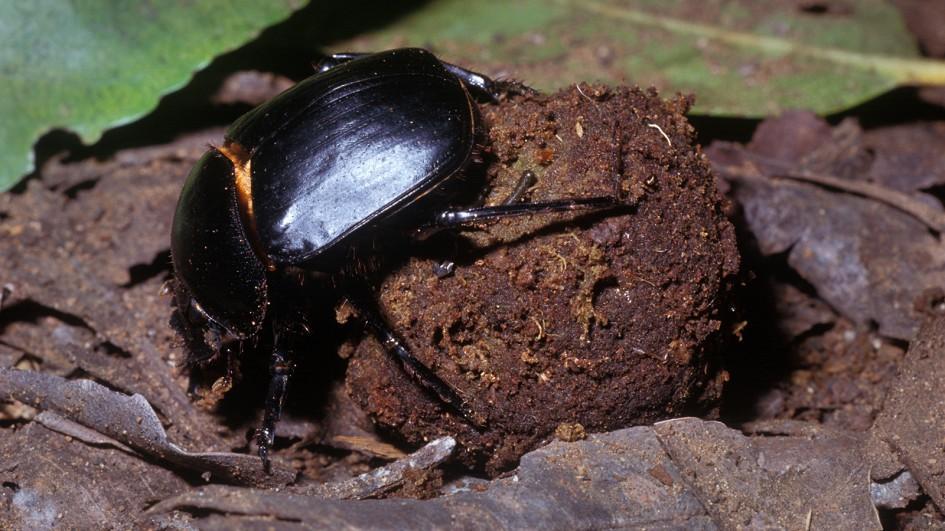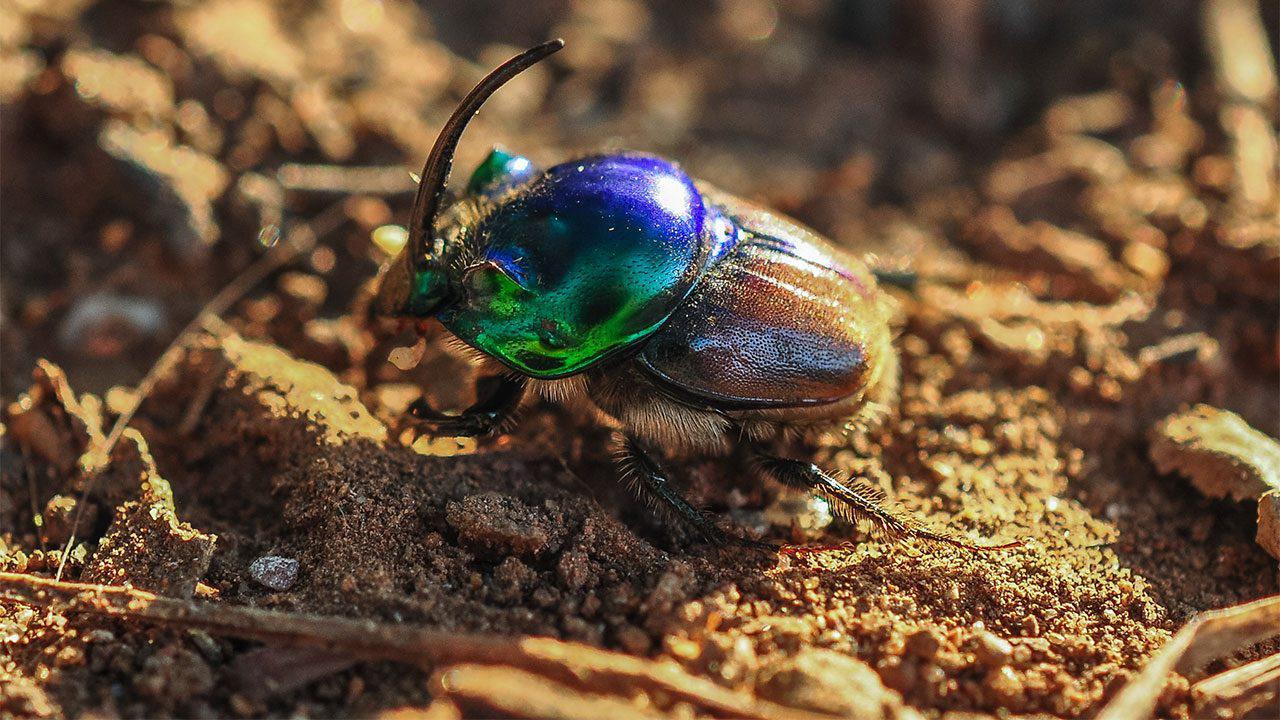The first image is the image on the left, the second image is the image on the right. Given the left and right images, does the statement "Each image has at least 2 dung beetles with a ball of dung." hold true? Answer yes or no. No. The first image is the image on the left, the second image is the image on the right. For the images shown, is this caption "There are two dung beetles." true? Answer yes or no. Yes. 